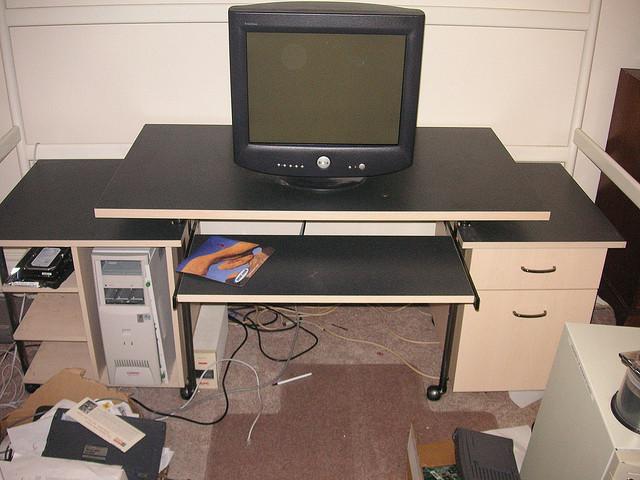Is the computer functional?
Short answer required. Yes. What is the computer sitting on?
Be succinct. Desk. How many drawers are there?
Write a very short answer. 2. 